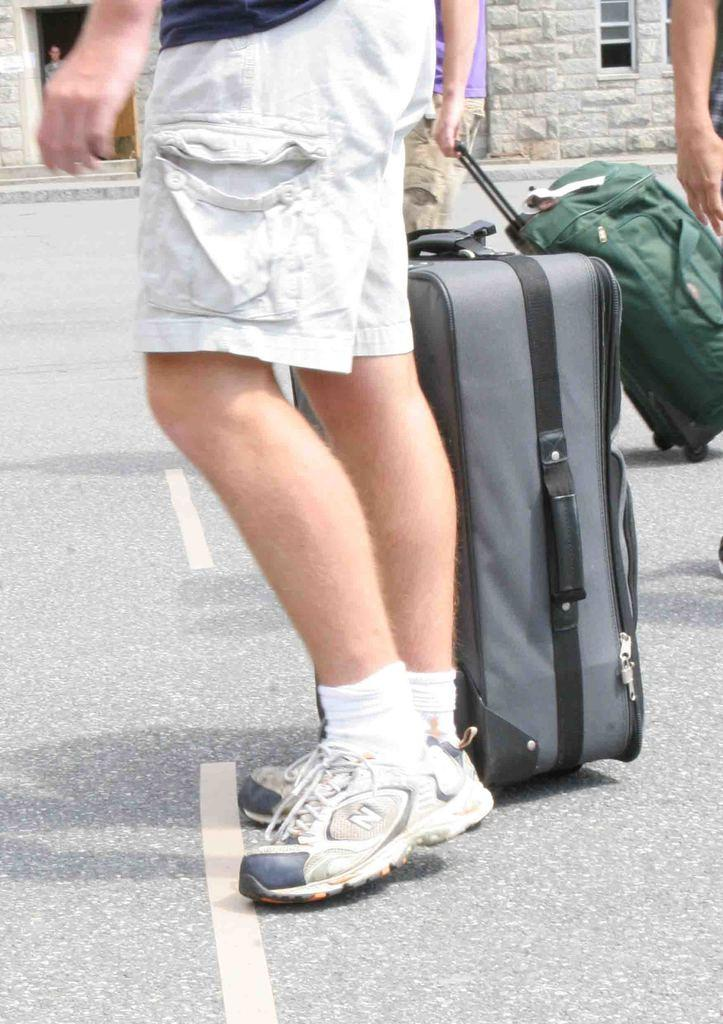What are the people in the image doing? The persons standing on the road are holding suitcases. What can be seen in the background of the image? There is a building visible in the background. What type of soap is being used by the persons in the image? There is no soap present in the image; the persons are holding suitcases. What kind of lumber can be seen in the image? There is no lumber present in the image; the persons are standing on a road with a building in the background. 